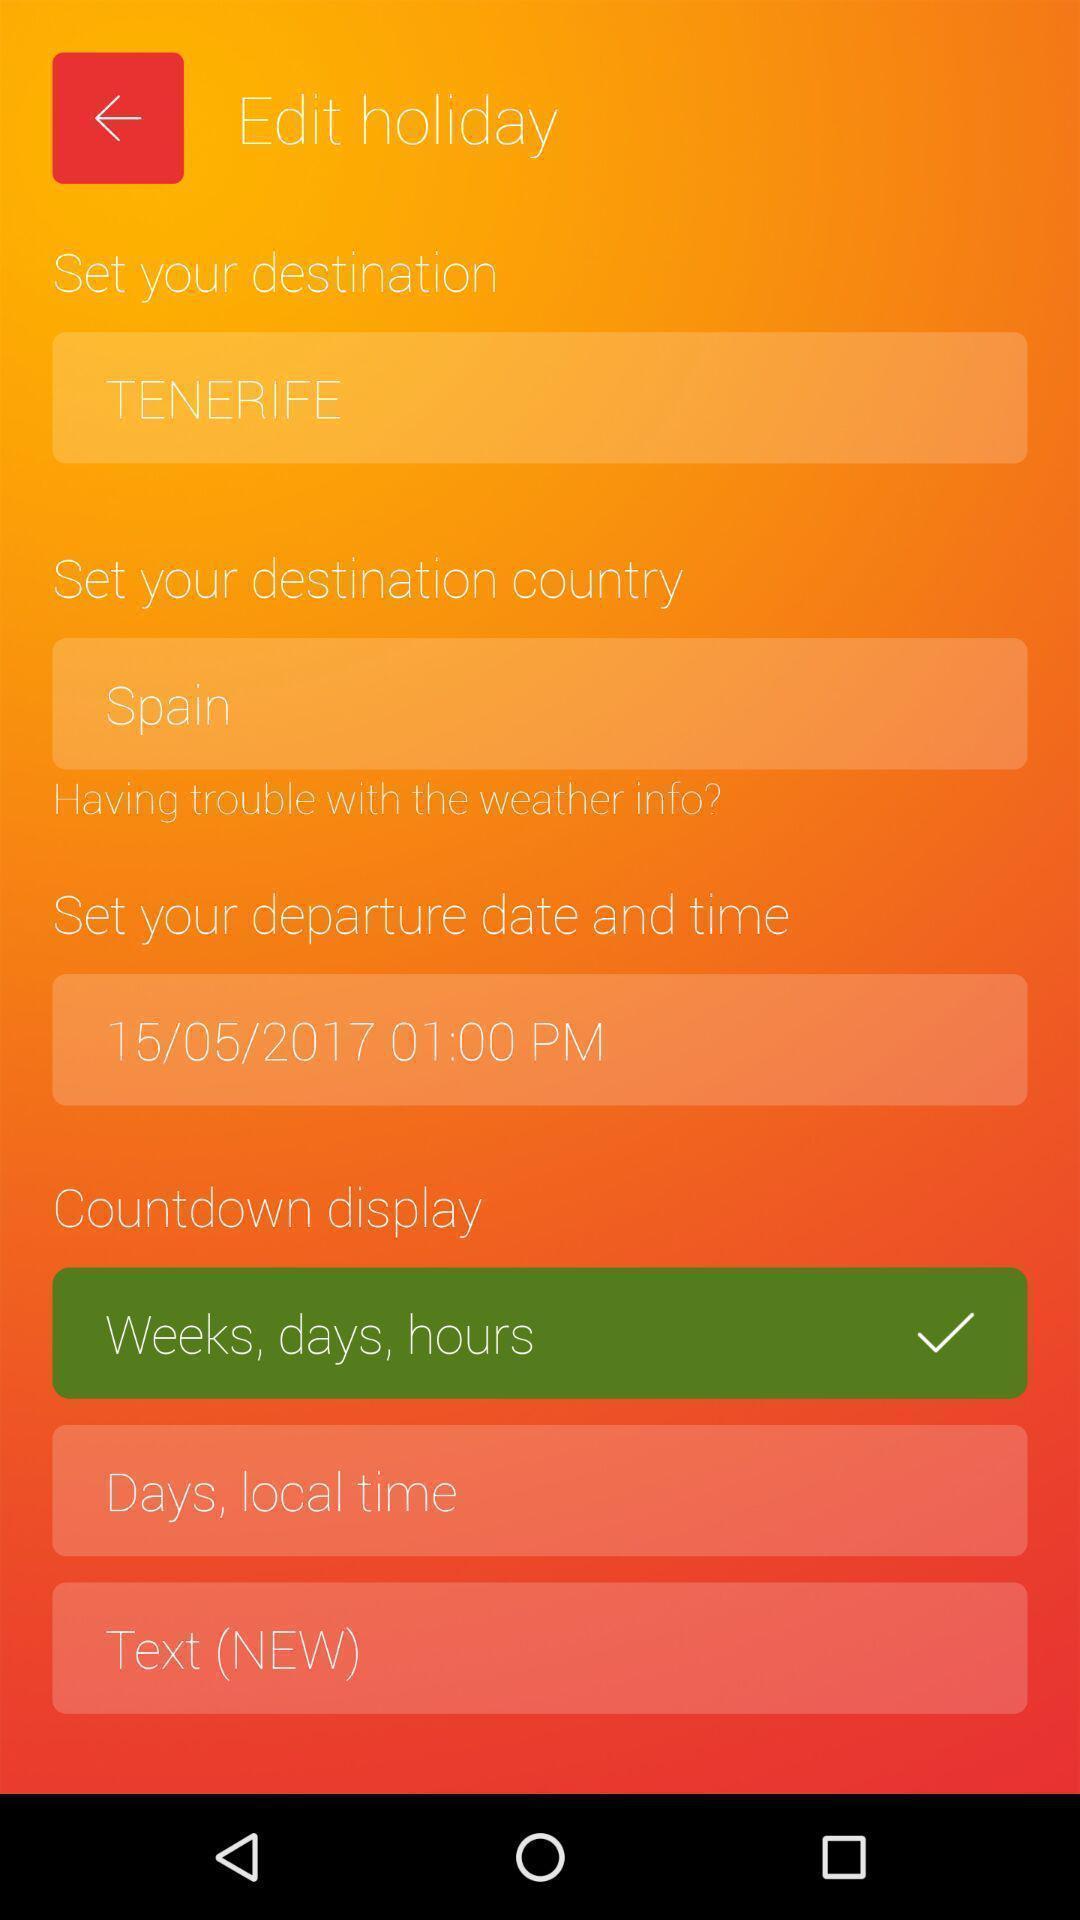Please provide a description for this image. Screen displaying editing page of a holiday trip. 